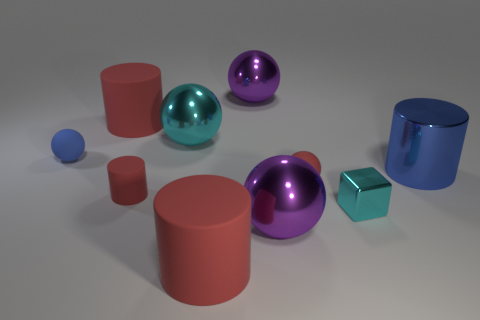Subtract all green spheres. How many red cylinders are left? 3 Subtract all small red matte spheres. How many spheres are left? 4 Subtract all blue spheres. How many spheres are left? 4 Subtract all brown spheres. Subtract all blue cylinders. How many spheres are left? 5 Subtract all blocks. How many objects are left? 9 Add 5 big blue things. How many big blue things exist? 6 Subtract 0 brown cubes. How many objects are left? 10 Subtract all purple shiny objects. Subtract all small red spheres. How many objects are left? 7 Add 9 blue spheres. How many blue spheres are left? 10 